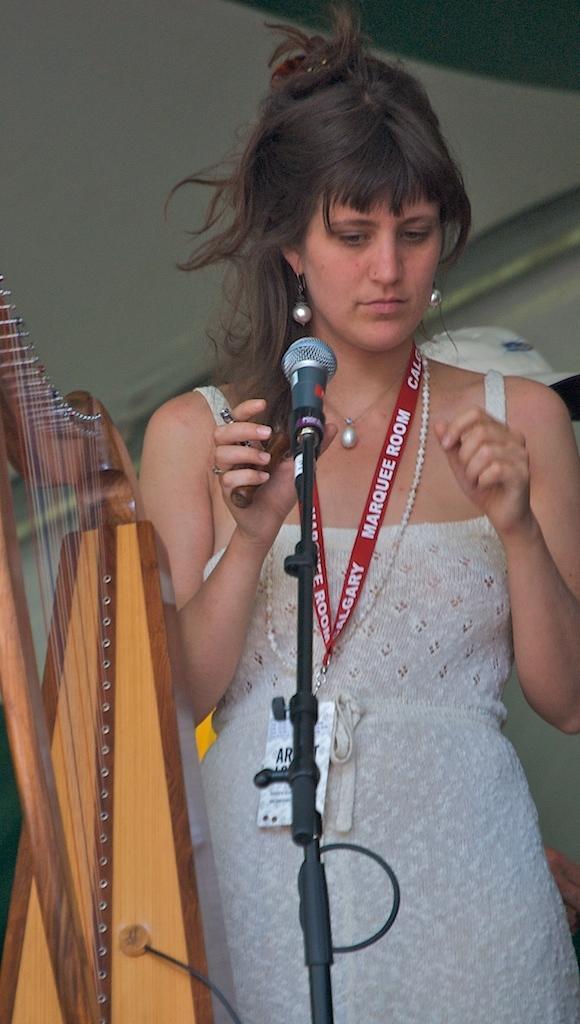In one or two sentences, can you explain what this image depicts? In this image, I can see a woman standing. In front of the woman, I can see a harp and a mike with a mike stand. Behind the woman, there is a cap. 